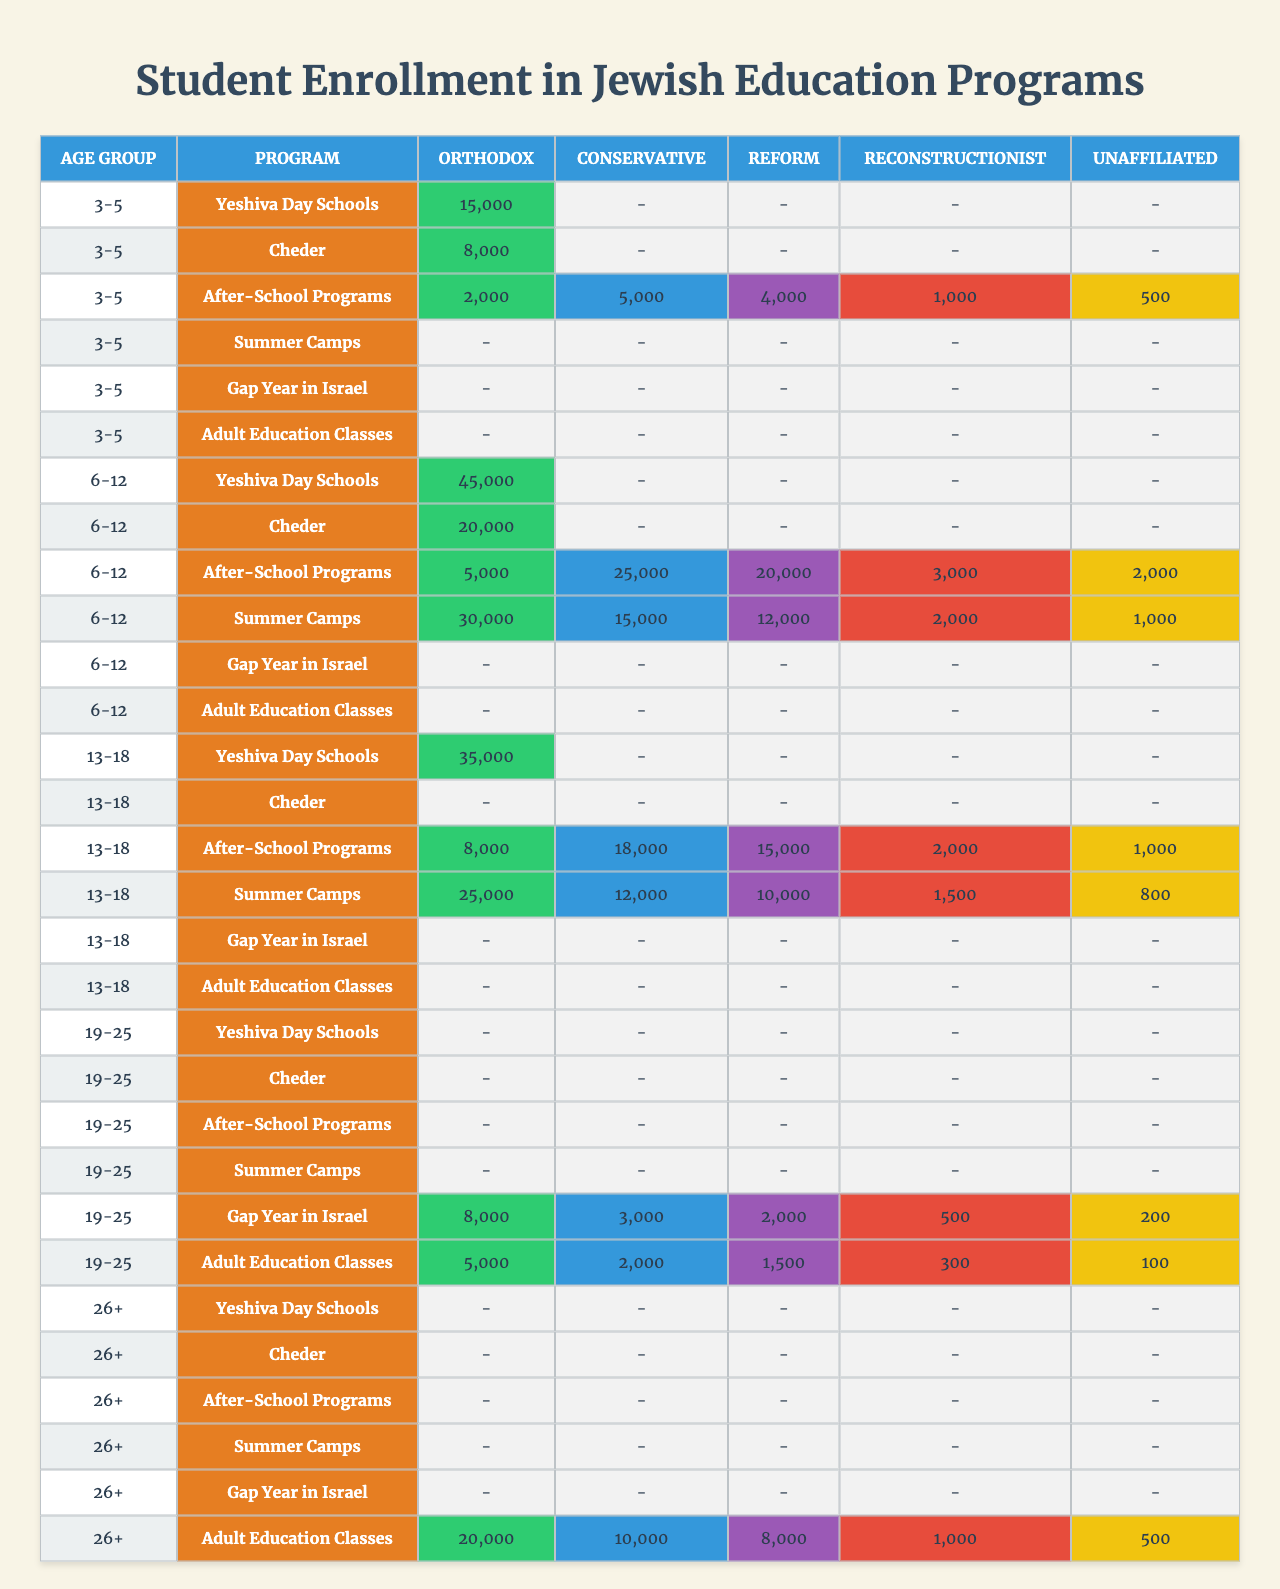What is the total enrollment in Orthodox Yeshiva Day Schools for the age group 6-12? For the age group 6-12, the enrollment in Orthodox Yeshiva Day Schools is 45,000.
Answer: 45,000 Which age group has the highest enrollment in Adult Education Classes for Conservative students? The age group 26+ has the highest enrollment in Adult Education Classes for Conservative students, with 10,000.
Answer: 10,000 How many students are enrolled in After-School Programs for the 3-5 age group across all denominations? For the 3-5 age group, enrollment in After-School Programs is 2,000 (Orthodox) + 5,000 (Conservative) + 4,000 (Reform) + 1,000 (Reconstructionist) + 500 (Unaffiliated) = 12,500.
Answer: 12,500 Is there any enrollment in summer camps for the age group 19-25? There is no enrollment recorded for summer camps in the age group 19-25, as this age group does not participate in summer camps according to the data.
Answer: No What is the total enrollment for all denominations in the Cheder program for the age group 3-5? The total enrollment for the Cheder program in the 3-5 age group is 8,000 (Orthodox). There are no other enrollments reported in Cheder for this age group.
Answer: 8,000 Which age group has the lowest total enrollment in After-School Programs for Reconstructionist students? The 3-5 age group has the lowest enrollment in After-School Programs for Reconstructionist students, with 1,000.
Answer: 1,000 How does the enrollment in Gap Year in Israel for Conservative students compare to that for Orthodox students in the age group 19-25? For the age group 19-25, enrollment in Gap Year in Israel is 3,000 (Conservative) compared to 8,000 (Orthodox). Therefore, Orthodox students have higher enrollment by 5,000 students.
Answer: Orthodox students have 5,000 more enrollments What is the total number of students enrolled in summer camps for the age group 13-18 across all denominations? Enrollment in summer camps for the age group 13-18: Orthodox (25,000) + Conservative (12,000) + Reform (10,000) + Reconstructionist (1,500) + Unaffiliated (800) = 49,300.
Answer: 49,300 Which age group has the least participation in the Gap Year in Israel program for Unaffiliated students? The 19-25 age group has the least participation in the Gap Year in Israel program for Unaffiliated students with 200 enrolled.
Answer: 200 Is the total enrollment in Adult Education Classes higher for Orthodox students compared to all other denominations combined for the age group 26+? Total enrollment for Orthodox students in Adult Education Classes for 26+ is 20,000. For other denominations combined, total enrollment is Conservative (10,000) + Reform (8,000) + Reconstructionist (1,000) + Unaffiliated (500) = 19,500. Thus, Orthodox students have higher enrollment by 500.
Answer: Yes 